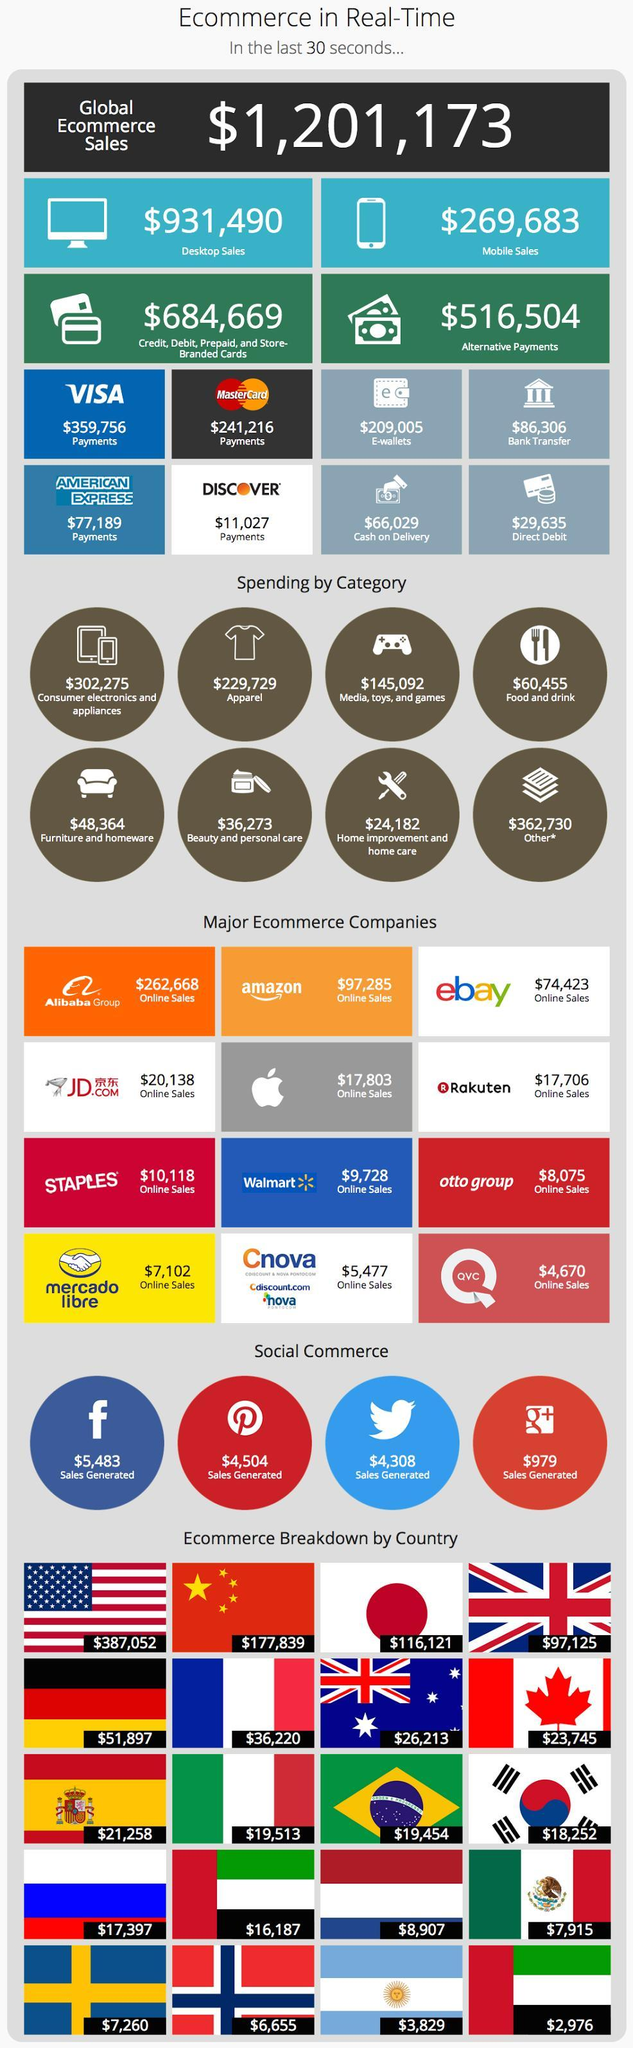Sales worth how much was generated through Facebook?
Answer the question with a short phrase. $5,483 What is the E-commerce value of US as per the infographics? $387,052 How much sales was generated through Twitter and Google plus combined? $5,287 How many flags are shown? 20 